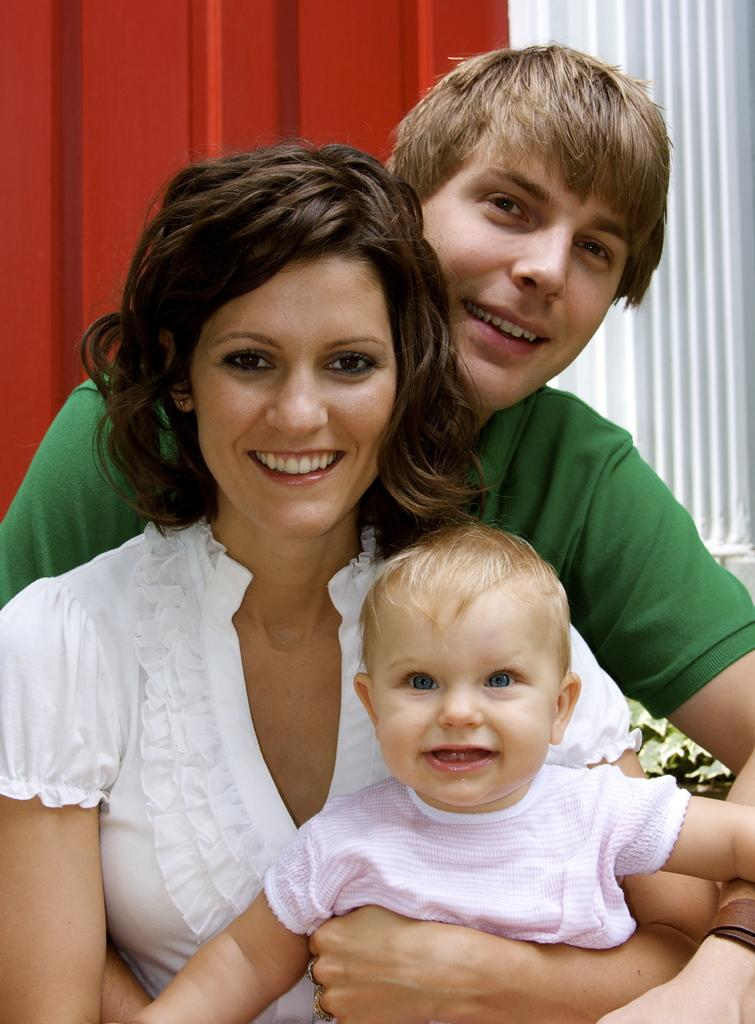How many people are present in the image? There are two people, a woman and a man, present in the image. What are the woman and man doing in the image? The woman and man are holding a kid in the image. What can be seen in the background of the image? There is a metal sheet and a plant in the background of the image. What type of mountain can be seen in the background of the image? There is no mountain present in the image; it features a woman, a man, a kid, a metal sheet, and a plant in the background. How many generations are represented in the image? The image only shows a woman, a man, and a kid, so it is not possible to determine the number of generations represented. 